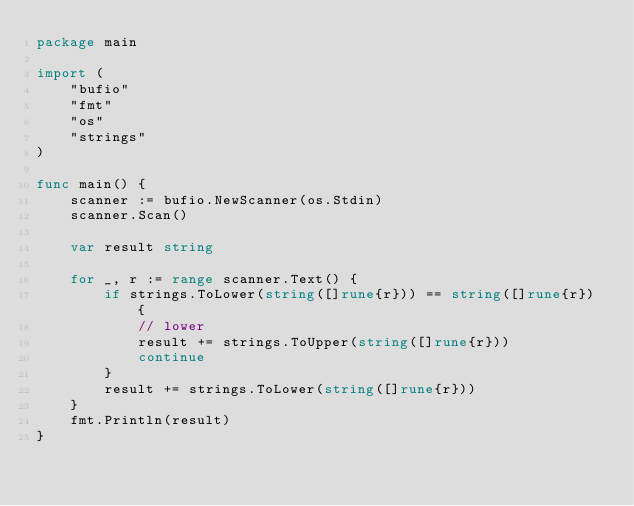<code> <loc_0><loc_0><loc_500><loc_500><_Go_>package main

import (
	"bufio"
	"fmt"
	"os"
	"strings"
)

func main() {
	scanner := bufio.NewScanner(os.Stdin)
	scanner.Scan()

	var result string

	for _, r := range scanner.Text() {
		if strings.ToLower(string([]rune{r})) == string([]rune{r}) {
			// lower
			result += strings.ToUpper(string([]rune{r}))
			continue
		}
		result += strings.ToLower(string([]rune{r}))
	}
	fmt.Println(result)
}

</code> 